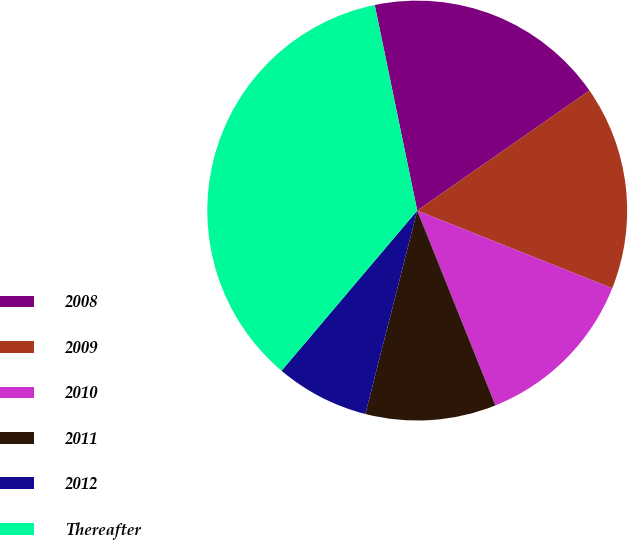<chart> <loc_0><loc_0><loc_500><loc_500><pie_chart><fcel>2008<fcel>2009<fcel>2010<fcel>2011<fcel>2012<fcel>Thereafter<nl><fcel>18.56%<fcel>15.72%<fcel>12.89%<fcel>10.05%<fcel>7.21%<fcel>35.57%<nl></chart> 